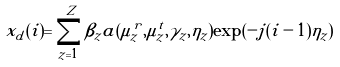<formula> <loc_0><loc_0><loc_500><loc_500>x _ { d } ( i ) = \sum _ { z = 1 } ^ { Z } \beta _ { z } a ( \mu ^ { r } _ { z } , \mu ^ { t } _ { z } , \gamma _ { z } , \eta _ { z } ) \exp ( - j ( i - 1 ) \eta _ { z } )</formula> 